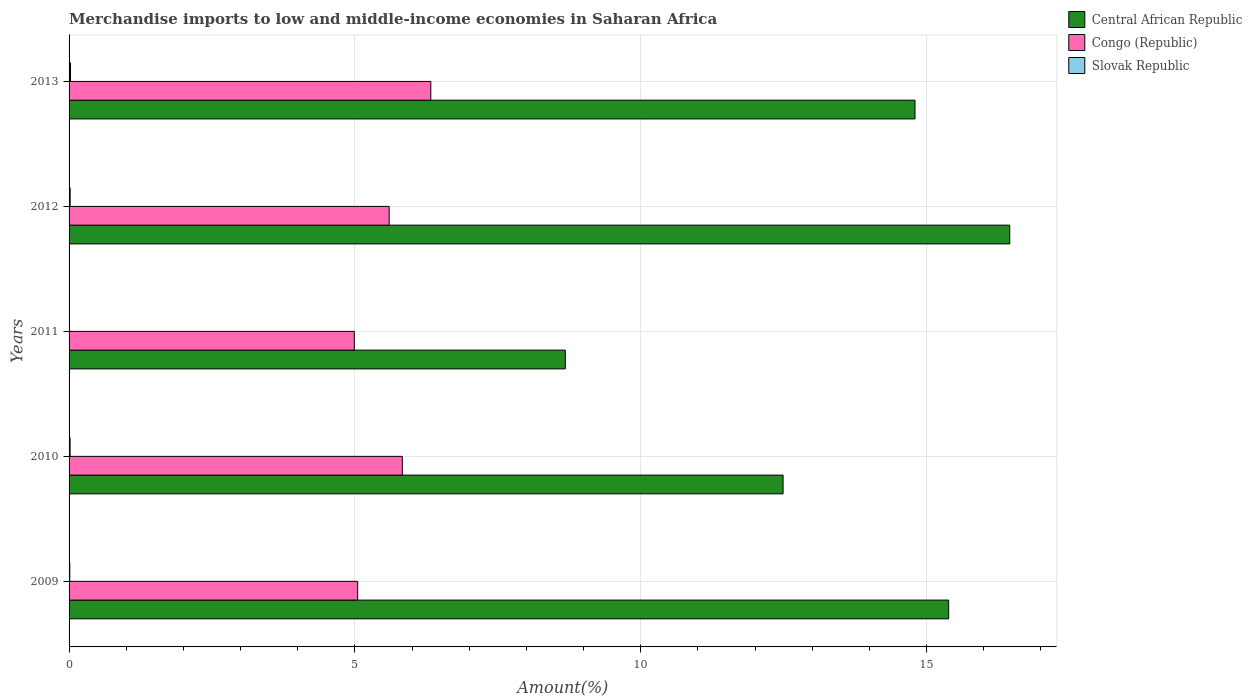Are the number of bars per tick equal to the number of legend labels?
Keep it short and to the point. Yes. How many bars are there on the 4th tick from the top?
Make the answer very short. 3. What is the label of the 2nd group of bars from the top?
Make the answer very short. 2012. In how many cases, is the number of bars for a given year not equal to the number of legend labels?
Keep it short and to the point. 0. What is the percentage of amount earned from merchandise imports in Slovak Republic in 2011?
Provide a succinct answer. 0.01. Across all years, what is the maximum percentage of amount earned from merchandise imports in Slovak Republic?
Ensure brevity in your answer.  0.03. Across all years, what is the minimum percentage of amount earned from merchandise imports in Congo (Republic)?
Keep it short and to the point. 4.99. In which year was the percentage of amount earned from merchandise imports in Central African Republic maximum?
Provide a succinct answer. 2012. What is the total percentage of amount earned from merchandise imports in Slovak Republic in the graph?
Provide a succinct answer. 0.08. What is the difference between the percentage of amount earned from merchandise imports in Congo (Republic) in 2012 and that in 2013?
Offer a very short reply. -0.73. What is the difference between the percentage of amount earned from merchandise imports in Congo (Republic) in 2009 and the percentage of amount earned from merchandise imports in Central African Republic in 2011?
Provide a succinct answer. -3.63. What is the average percentage of amount earned from merchandise imports in Congo (Republic) per year?
Ensure brevity in your answer.  5.56. In the year 2012, what is the difference between the percentage of amount earned from merchandise imports in Slovak Republic and percentage of amount earned from merchandise imports in Central African Republic?
Your response must be concise. -16.43. What is the ratio of the percentage of amount earned from merchandise imports in Slovak Republic in 2011 to that in 2012?
Provide a short and direct response. 0.3. What is the difference between the highest and the second highest percentage of amount earned from merchandise imports in Congo (Republic)?
Give a very brief answer. 0.5. What is the difference between the highest and the lowest percentage of amount earned from merchandise imports in Congo (Republic)?
Provide a short and direct response. 1.34. What does the 2nd bar from the top in 2011 represents?
Ensure brevity in your answer.  Congo (Republic). What does the 2nd bar from the bottom in 2012 represents?
Make the answer very short. Congo (Republic). Is it the case that in every year, the sum of the percentage of amount earned from merchandise imports in Central African Republic and percentage of amount earned from merchandise imports in Slovak Republic is greater than the percentage of amount earned from merchandise imports in Congo (Republic)?
Your response must be concise. Yes. How many bars are there?
Offer a terse response. 15. Are all the bars in the graph horizontal?
Provide a short and direct response. Yes. How many years are there in the graph?
Provide a short and direct response. 5. What is the difference between two consecutive major ticks on the X-axis?
Your answer should be compact. 5. Does the graph contain any zero values?
Keep it short and to the point. No. Where does the legend appear in the graph?
Offer a very short reply. Top right. How are the legend labels stacked?
Make the answer very short. Vertical. What is the title of the graph?
Make the answer very short. Merchandise imports to low and middle-income economies in Saharan Africa. What is the label or title of the X-axis?
Provide a short and direct response. Amount(%). What is the Amount(%) of Central African Republic in 2009?
Make the answer very short. 15.39. What is the Amount(%) of Congo (Republic) in 2009?
Ensure brevity in your answer.  5.05. What is the Amount(%) of Slovak Republic in 2009?
Make the answer very short. 0.01. What is the Amount(%) in Central African Republic in 2010?
Give a very brief answer. 12.49. What is the Amount(%) of Congo (Republic) in 2010?
Provide a short and direct response. 5.83. What is the Amount(%) in Slovak Republic in 2010?
Offer a very short reply. 0.02. What is the Amount(%) in Central African Republic in 2011?
Your answer should be very brief. 8.68. What is the Amount(%) of Congo (Republic) in 2011?
Keep it short and to the point. 4.99. What is the Amount(%) of Slovak Republic in 2011?
Offer a very short reply. 0.01. What is the Amount(%) of Central African Republic in 2012?
Make the answer very short. 16.45. What is the Amount(%) of Congo (Republic) in 2012?
Ensure brevity in your answer.  5.6. What is the Amount(%) of Slovak Republic in 2012?
Your answer should be compact. 0.02. What is the Amount(%) in Central African Republic in 2013?
Your response must be concise. 14.8. What is the Amount(%) in Congo (Republic) in 2013?
Offer a terse response. 6.33. What is the Amount(%) in Slovak Republic in 2013?
Your response must be concise. 0.03. Across all years, what is the maximum Amount(%) in Central African Republic?
Give a very brief answer. 16.45. Across all years, what is the maximum Amount(%) of Congo (Republic)?
Give a very brief answer. 6.33. Across all years, what is the maximum Amount(%) of Slovak Republic?
Provide a succinct answer. 0.03. Across all years, what is the minimum Amount(%) in Central African Republic?
Make the answer very short. 8.68. Across all years, what is the minimum Amount(%) in Congo (Republic)?
Provide a short and direct response. 4.99. Across all years, what is the minimum Amount(%) of Slovak Republic?
Your answer should be very brief. 0.01. What is the total Amount(%) in Central African Republic in the graph?
Make the answer very short. 67.8. What is the total Amount(%) in Congo (Republic) in the graph?
Ensure brevity in your answer.  27.79. What is the total Amount(%) in Slovak Republic in the graph?
Make the answer very short. 0.08. What is the difference between the Amount(%) of Central African Republic in 2009 and that in 2010?
Provide a succinct answer. 2.9. What is the difference between the Amount(%) in Congo (Republic) in 2009 and that in 2010?
Make the answer very short. -0.78. What is the difference between the Amount(%) of Slovak Republic in 2009 and that in 2010?
Keep it short and to the point. -0.01. What is the difference between the Amount(%) of Central African Republic in 2009 and that in 2011?
Provide a succinct answer. 6.71. What is the difference between the Amount(%) of Congo (Republic) in 2009 and that in 2011?
Your answer should be compact. 0.06. What is the difference between the Amount(%) in Slovak Republic in 2009 and that in 2011?
Ensure brevity in your answer.  0.01. What is the difference between the Amount(%) in Central African Republic in 2009 and that in 2012?
Provide a short and direct response. -1.07. What is the difference between the Amount(%) in Congo (Republic) in 2009 and that in 2012?
Your answer should be very brief. -0.55. What is the difference between the Amount(%) in Slovak Republic in 2009 and that in 2012?
Ensure brevity in your answer.  -0.01. What is the difference between the Amount(%) of Central African Republic in 2009 and that in 2013?
Offer a terse response. 0.59. What is the difference between the Amount(%) in Congo (Republic) in 2009 and that in 2013?
Ensure brevity in your answer.  -1.28. What is the difference between the Amount(%) in Slovak Republic in 2009 and that in 2013?
Provide a succinct answer. -0.01. What is the difference between the Amount(%) in Central African Republic in 2010 and that in 2011?
Keep it short and to the point. 3.81. What is the difference between the Amount(%) of Congo (Republic) in 2010 and that in 2011?
Your response must be concise. 0.84. What is the difference between the Amount(%) in Slovak Republic in 2010 and that in 2011?
Offer a very short reply. 0.01. What is the difference between the Amount(%) in Central African Republic in 2010 and that in 2012?
Your answer should be very brief. -3.96. What is the difference between the Amount(%) in Congo (Republic) in 2010 and that in 2012?
Ensure brevity in your answer.  0.23. What is the difference between the Amount(%) in Slovak Republic in 2010 and that in 2012?
Keep it short and to the point. -0. What is the difference between the Amount(%) of Central African Republic in 2010 and that in 2013?
Provide a succinct answer. -2.31. What is the difference between the Amount(%) in Congo (Republic) in 2010 and that in 2013?
Your answer should be very brief. -0.5. What is the difference between the Amount(%) of Slovak Republic in 2010 and that in 2013?
Ensure brevity in your answer.  -0.01. What is the difference between the Amount(%) in Central African Republic in 2011 and that in 2012?
Make the answer very short. -7.77. What is the difference between the Amount(%) of Congo (Republic) in 2011 and that in 2012?
Keep it short and to the point. -0.61. What is the difference between the Amount(%) of Slovak Republic in 2011 and that in 2012?
Your answer should be very brief. -0.01. What is the difference between the Amount(%) in Central African Republic in 2011 and that in 2013?
Ensure brevity in your answer.  -6.12. What is the difference between the Amount(%) of Congo (Republic) in 2011 and that in 2013?
Your answer should be very brief. -1.34. What is the difference between the Amount(%) in Slovak Republic in 2011 and that in 2013?
Offer a terse response. -0.02. What is the difference between the Amount(%) in Central African Republic in 2012 and that in 2013?
Offer a terse response. 1.66. What is the difference between the Amount(%) of Congo (Republic) in 2012 and that in 2013?
Provide a short and direct response. -0.73. What is the difference between the Amount(%) of Slovak Republic in 2012 and that in 2013?
Provide a succinct answer. -0.01. What is the difference between the Amount(%) of Central African Republic in 2009 and the Amount(%) of Congo (Republic) in 2010?
Your response must be concise. 9.56. What is the difference between the Amount(%) in Central African Republic in 2009 and the Amount(%) in Slovak Republic in 2010?
Your answer should be compact. 15.37. What is the difference between the Amount(%) of Congo (Republic) in 2009 and the Amount(%) of Slovak Republic in 2010?
Your answer should be compact. 5.03. What is the difference between the Amount(%) in Central African Republic in 2009 and the Amount(%) in Congo (Republic) in 2011?
Your response must be concise. 10.4. What is the difference between the Amount(%) in Central African Republic in 2009 and the Amount(%) in Slovak Republic in 2011?
Your answer should be compact. 15.38. What is the difference between the Amount(%) in Congo (Republic) in 2009 and the Amount(%) in Slovak Republic in 2011?
Provide a succinct answer. 5.04. What is the difference between the Amount(%) in Central African Republic in 2009 and the Amount(%) in Congo (Republic) in 2012?
Keep it short and to the point. 9.79. What is the difference between the Amount(%) of Central African Republic in 2009 and the Amount(%) of Slovak Republic in 2012?
Offer a terse response. 15.37. What is the difference between the Amount(%) in Congo (Republic) in 2009 and the Amount(%) in Slovak Republic in 2012?
Offer a very short reply. 5.03. What is the difference between the Amount(%) in Central African Republic in 2009 and the Amount(%) in Congo (Republic) in 2013?
Offer a terse response. 9.06. What is the difference between the Amount(%) of Central African Republic in 2009 and the Amount(%) of Slovak Republic in 2013?
Provide a short and direct response. 15.36. What is the difference between the Amount(%) of Congo (Republic) in 2009 and the Amount(%) of Slovak Republic in 2013?
Offer a very short reply. 5.02. What is the difference between the Amount(%) of Central African Republic in 2010 and the Amount(%) of Congo (Republic) in 2011?
Make the answer very short. 7.5. What is the difference between the Amount(%) of Central African Republic in 2010 and the Amount(%) of Slovak Republic in 2011?
Give a very brief answer. 12.48. What is the difference between the Amount(%) in Congo (Republic) in 2010 and the Amount(%) in Slovak Republic in 2011?
Provide a short and direct response. 5.82. What is the difference between the Amount(%) in Central African Republic in 2010 and the Amount(%) in Congo (Republic) in 2012?
Offer a terse response. 6.89. What is the difference between the Amount(%) of Central African Republic in 2010 and the Amount(%) of Slovak Republic in 2012?
Make the answer very short. 12.47. What is the difference between the Amount(%) of Congo (Republic) in 2010 and the Amount(%) of Slovak Republic in 2012?
Your answer should be compact. 5.81. What is the difference between the Amount(%) of Central African Republic in 2010 and the Amount(%) of Congo (Republic) in 2013?
Your answer should be compact. 6.16. What is the difference between the Amount(%) in Central African Republic in 2010 and the Amount(%) in Slovak Republic in 2013?
Ensure brevity in your answer.  12.46. What is the difference between the Amount(%) of Congo (Republic) in 2010 and the Amount(%) of Slovak Republic in 2013?
Ensure brevity in your answer.  5.8. What is the difference between the Amount(%) in Central African Republic in 2011 and the Amount(%) in Congo (Republic) in 2012?
Offer a very short reply. 3.08. What is the difference between the Amount(%) of Central African Republic in 2011 and the Amount(%) of Slovak Republic in 2012?
Give a very brief answer. 8.66. What is the difference between the Amount(%) in Congo (Republic) in 2011 and the Amount(%) in Slovak Republic in 2012?
Keep it short and to the point. 4.97. What is the difference between the Amount(%) in Central African Republic in 2011 and the Amount(%) in Congo (Republic) in 2013?
Keep it short and to the point. 2.35. What is the difference between the Amount(%) in Central African Republic in 2011 and the Amount(%) in Slovak Republic in 2013?
Make the answer very short. 8.65. What is the difference between the Amount(%) in Congo (Republic) in 2011 and the Amount(%) in Slovak Republic in 2013?
Your response must be concise. 4.96. What is the difference between the Amount(%) of Central African Republic in 2012 and the Amount(%) of Congo (Republic) in 2013?
Give a very brief answer. 10.13. What is the difference between the Amount(%) in Central African Republic in 2012 and the Amount(%) in Slovak Republic in 2013?
Offer a terse response. 16.43. What is the difference between the Amount(%) in Congo (Republic) in 2012 and the Amount(%) in Slovak Republic in 2013?
Make the answer very short. 5.57. What is the average Amount(%) of Central African Republic per year?
Give a very brief answer. 13.56. What is the average Amount(%) in Congo (Republic) per year?
Offer a terse response. 5.56. What is the average Amount(%) of Slovak Republic per year?
Provide a succinct answer. 0.02. In the year 2009, what is the difference between the Amount(%) of Central African Republic and Amount(%) of Congo (Republic)?
Your answer should be compact. 10.34. In the year 2009, what is the difference between the Amount(%) of Central African Republic and Amount(%) of Slovak Republic?
Make the answer very short. 15.37. In the year 2009, what is the difference between the Amount(%) of Congo (Republic) and Amount(%) of Slovak Republic?
Your response must be concise. 5.04. In the year 2010, what is the difference between the Amount(%) of Central African Republic and Amount(%) of Congo (Republic)?
Keep it short and to the point. 6.66. In the year 2010, what is the difference between the Amount(%) in Central African Republic and Amount(%) in Slovak Republic?
Offer a very short reply. 12.47. In the year 2010, what is the difference between the Amount(%) of Congo (Republic) and Amount(%) of Slovak Republic?
Offer a very short reply. 5.81. In the year 2011, what is the difference between the Amount(%) in Central African Republic and Amount(%) in Congo (Republic)?
Make the answer very short. 3.69. In the year 2011, what is the difference between the Amount(%) in Central African Republic and Amount(%) in Slovak Republic?
Offer a terse response. 8.67. In the year 2011, what is the difference between the Amount(%) in Congo (Republic) and Amount(%) in Slovak Republic?
Keep it short and to the point. 4.98. In the year 2012, what is the difference between the Amount(%) of Central African Republic and Amount(%) of Congo (Republic)?
Ensure brevity in your answer.  10.85. In the year 2012, what is the difference between the Amount(%) in Central African Republic and Amount(%) in Slovak Republic?
Provide a short and direct response. 16.43. In the year 2012, what is the difference between the Amount(%) in Congo (Republic) and Amount(%) in Slovak Republic?
Give a very brief answer. 5.58. In the year 2013, what is the difference between the Amount(%) in Central African Republic and Amount(%) in Congo (Republic)?
Provide a succinct answer. 8.47. In the year 2013, what is the difference between the Amount(%) of Central African Republic and Amount(%) of Slovak Republic?
Make the answer very short. 14.77. In the year 2013, what is the difference between the Amount(%) in Congo (Republic) and Amount(%) in Slovak Republic?
Provide a succinct answer. 6.3. What is the ratio of the Amount(%) of Central African Republic in 2009 to that in 2010?
Provide a succinct answer. 1.23. What is the ratio of the Amount(%) of Congo (Republic) in 2009 to that in 2010?
Your answer should be very brief. 0.87. What is the ratio of the Amount(%) in Slovak Republic in 2009 to that in 2010?
Your response must be concise. 0.7. What is the ratio of the Amount(%) in Central African Republic in 2009 to that in 2011?
Provide a short and direct response. 1.77. What is the ratio of the Amount(%) of Congo (Republic) in 2009 to that in 2011?
Offer a terse response. 1.01. What is the ratio of the Amount(%) in Slovak Republic in 2009 to that in 2011?
Provide a succinct answer. 2.2. What is the ratio of the Amount(%) of Central African Republic in 2009 to that in 2012?
Your answer should be very brief. 0.94. What is the ratio of the Amount(%) in Congo (Republic) in 2009 to that in 2012?
Keep it short and to the point. 0.9. What is the ratio of the Amount(%) of Slovak Republic in 2009 to that in 2012?
Your answer should be very brief. 0.66. What is the ratio of the Amount(%) in Central African Republic in 2009 to that in 2013?
Keep it short and to the point. 1.04. What is the ratio of the Amount(%) of Congo (Republic) in 2009 to that in 2013?
Give a very brief answer. 0.8. What is the ratio of the Amount(%) in Slovak Republic in 2009 to that in 2013?
Ensure brevity in your answer.  0.5. What is the ratio of the Amount(%) in Central African Republic in 2010 to that in 2011?
Provide a succinct answer. 1.44. What is the ratio of the Amount(%) in Congo (Republic) in 2010 to that in 2011?
Provide a succinct answer. 1.17. What is the ratio of the Amount(%) of Slovak Republic in 2010 to that in 2011?
Offer a very short reply. 3.15. What is the ratio of the Amount(%) in Central African Republic in 2010 to that in 2012?
Your response must be concise. 0.76. What is the ratio of the Amount(%) in Congo (Republic) in 2010 to that in 2012?
Provide a succinct answer. 1.04. What is the ratio of the Amount(%) in Slovak Republic in 2010 to that in 2012?
Keep it short and to the point. 0.95. What is the ratio of the Amount(%) in Central African Republic in 2010 to that in 2013?
Your response must be concise. 0.84. What is the ratio of the Amount(%) in Congo (Republic) in 2010 to that in 2013?
Give a very brief answer. 0.92. What is the ratio of the Amount(%) of Slovak Republic in 2010 to that in 2013?
Keep it short and to the point. 0.71. What is the ratio of the Amount(%) of Central African Republic in 2011 to that in 2012?
Offer a terse response. 0.53. What is the ratio of the Amount(%) of Congo (Republic) in 2011 to that in 2012?
Provide a short and direct response. 0.89. What is the ratio of the Amount(%) of Slovak Republic in 2011 to that in 2012?
Ensure brevity in your answer.  0.3. What is the ratio of the Amount(%) of Central African Republic in 2011 to that in 2013?
Make the answer very short. 0.59. What is the ratio of the Amount(%) in Congo (Republic) in 2011 to that in 2013?
Offer a terse response. 0.79. What is the ratio of the Amount(%) of Slovak Republic in 2011 to that in 2013?
Offer a terse response. 0.23. What is the ratio of the Amount(%) of Central African Republic in 2012 to that in 2013?
Your response must be concise. 1.11. What is the ratio of the Amount(%) in Congo (Republic) in 2012 to that in 2013?
Provide a succinct answer. 0.88. What is the ratio of the Amount(%) of Slovak Republic in 2012 to that in 2013?
Your response must be concise. 0.75. What is the difference between the highest and the second highest Amount(%) of Central African Republic?
Keep it short and to the point. 1.07. What is the difference between the highest and the second highest Amount(%) of Congo (Republic)?
Your response must be concise. 0.5. What is the difference between the highest and the second highest Amount(%) in Slovak Republic?
Your response must be concise. 0.01. What is the difference between the highest and the lowest Amount(%) of Central African Republic?
Provide a short and direct response. 7.77. What is the difference between the highest and the lowest Amount(%) in Congo (Republic)?
Make the answer very short. 1.34. What is the difference between the highest and the lowest Amount(%) in Slovak Republic?
Your answer should be compact. 0.02. 